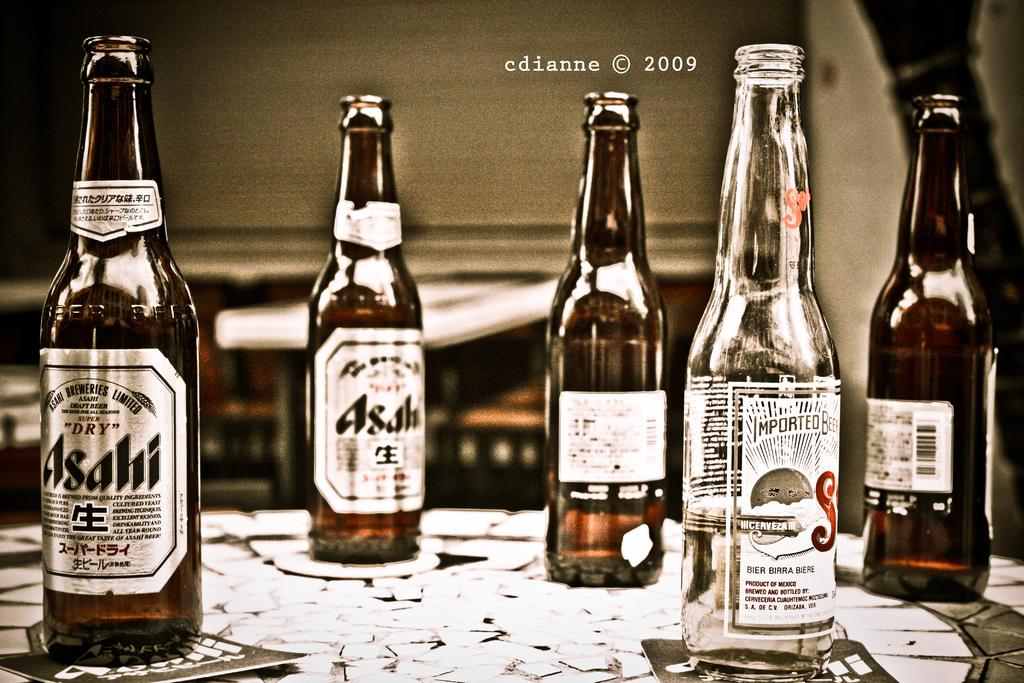What is the main subject of the image? The main subject of the image is many bottles. Where are the bottles located in the image? The bottles are on a table in the image. What can be seen on the bottles? There are logos on the bottles. Can you tell me how many cards are being used to play a game with the yam in the image? There is no card or yam present in the image; it only features many bottles on a table. 